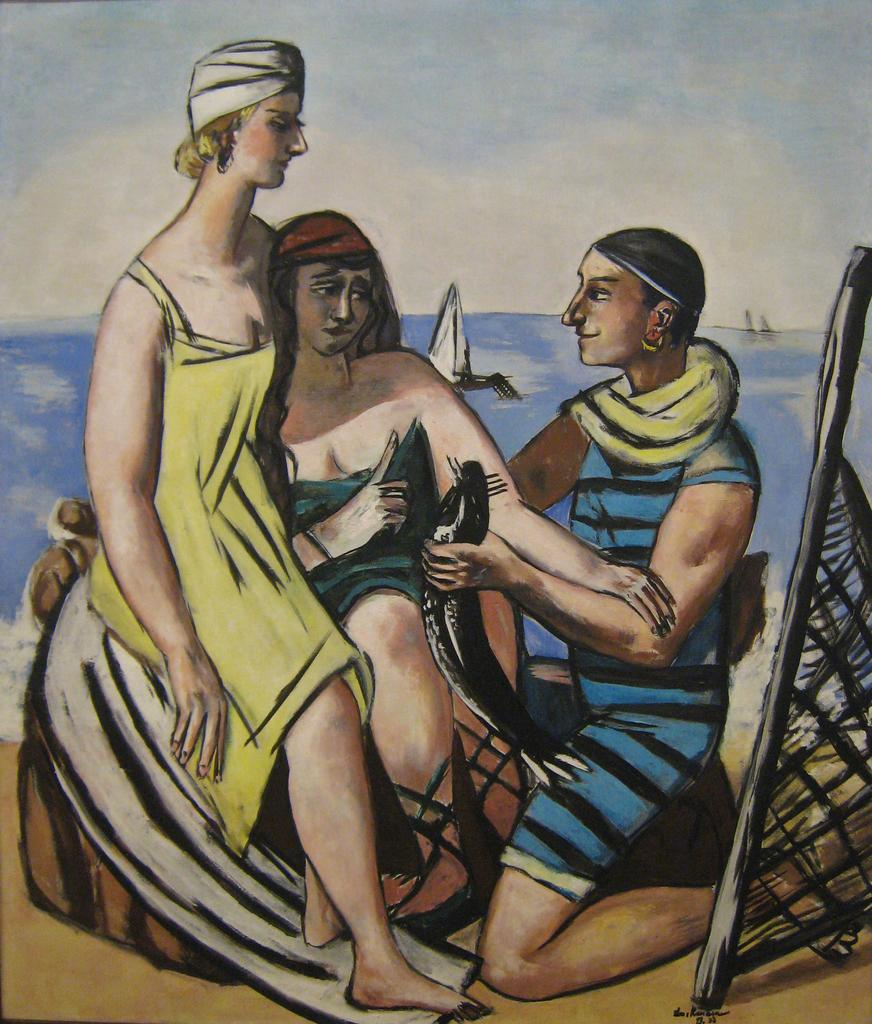What is the main subject of the image? There is a painting in the image. What is depicted in the painting? The painting depicts three persons. Are there any natural elements in the painting? Yes, the painting includes water. What type of vehicle is present in the painting? The painting features a boat. Can you see a pen being used by one of the persons in the painting? There is no pen visible in the painting; it only depicts three persons, water, and a boat. 